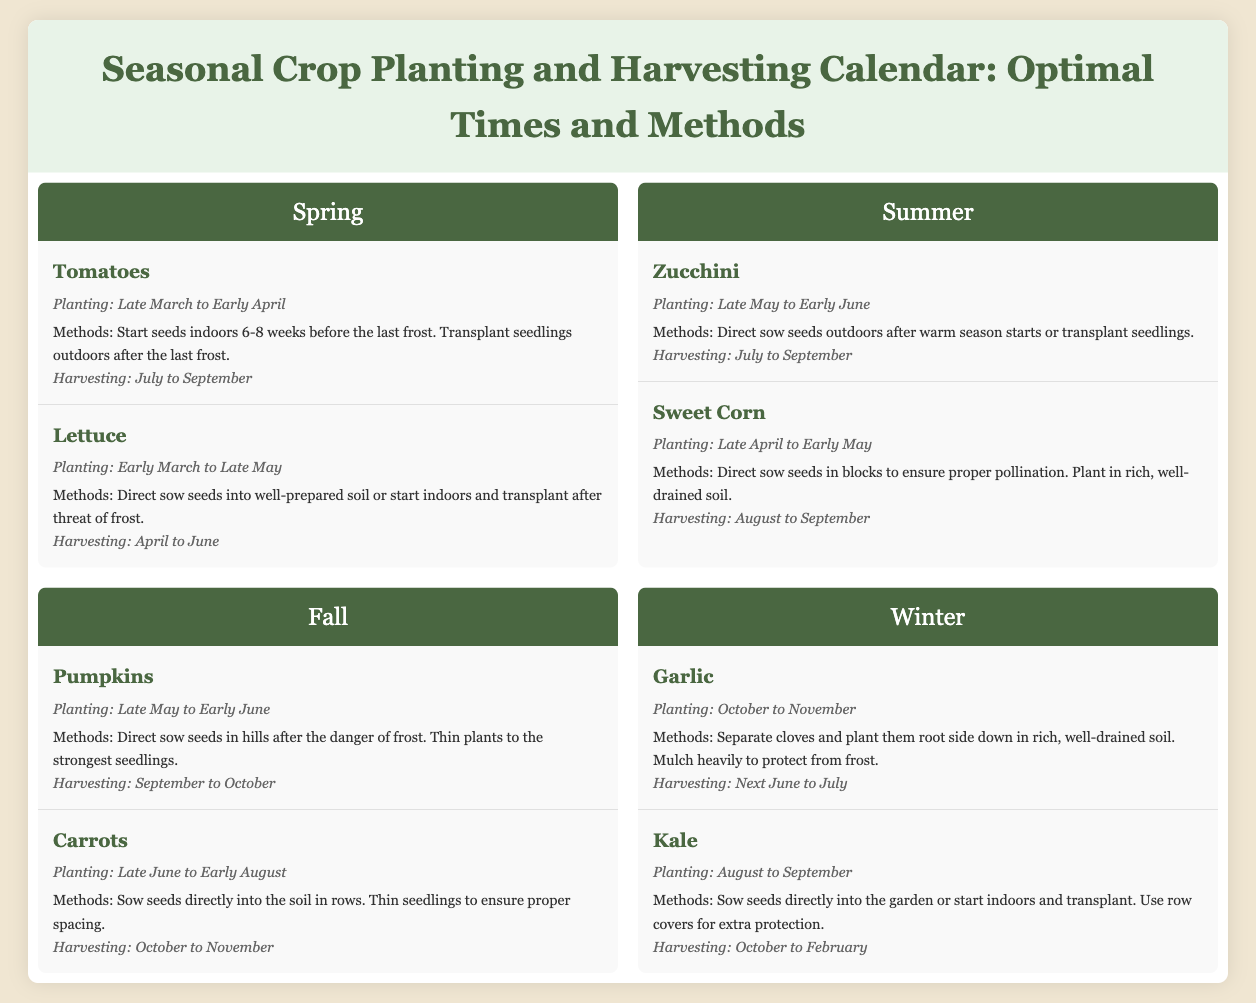What is the planting time for tomatoes? The planting time for tomatoes is specified as "Late March to Early April" in the document.
Answer: Late March to Early April When do you harvest carrots? The document states that carrots are harvested "October to November."
Answer: October to November What methods are recommended for planting garlic? The document mentions the methods as "Separate cloves and plant them root side down in rich, well-drained soil. Mulch heavily to protect from frost."
Answer: Separate cloves and plant them root side down Which crop has the earliest harvesting time in Spring? The earliest crop mentioned for harvesting in Spring is lettuce, which is harvested "April to June."
Answer: Lettuce In which season do you plant zucchini? The planting time for zucchini is listed as "Late May to Early June," which is in the summer season.
Answer: Summer How many crops are listed for the Winter season? The document details two crops for the Winter season: garlic and kale.
Answer: Two What is the harvesting time for sweet corn? The harvesting time for sweet corn is specified as "August to September" in the document.
Answer: August to September What is the planting method for pumpkins? The planting method for pumpkins involves "Direct sow seeds in hills after the danger of frost."
Answer: Direct sow seeds in hills 